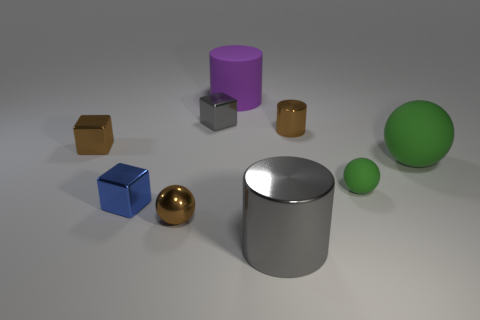Add 1 tiny gray metallic things. How many objects exist? 10 Subtract all blocks. How many objects are left? 6 Add 5 brown metal cylinders. How many brown metal cylinders are left? 6 Add 9 matte cylinders. How many matte cylinders exist? 10 Subtract 0 cyan blocks. How many objects are left? 9 Subtract all tiny blue metal balls. Subtract all spheres. How many objects are left? 6 